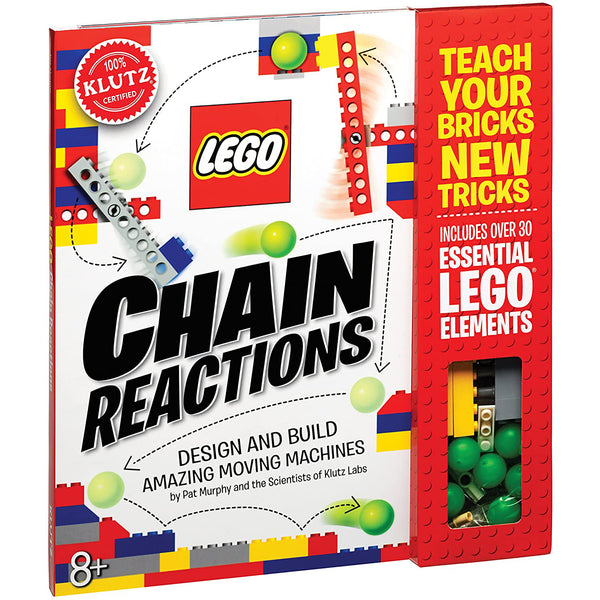What are some educational benefits, specifically in physics and engineering, that children can gain from building with LEGO sets like the one shown? Building with LEGO sets such as 'Chain Reactions' can profoundly impact educational development, particularly in physics and engineering. These activities encourage hands-on learning where children can explore concepts of force, motion, and mechanical design. As they assemble pieces to create functioning models, they engage in problem-solving and critical thinking. It provides a tangible way to understand abstract concepts like energy conservation and mechanical efficiency. Moreover, such building projects spark curiosity and can lead to a deeper interest in science and technology fields. 